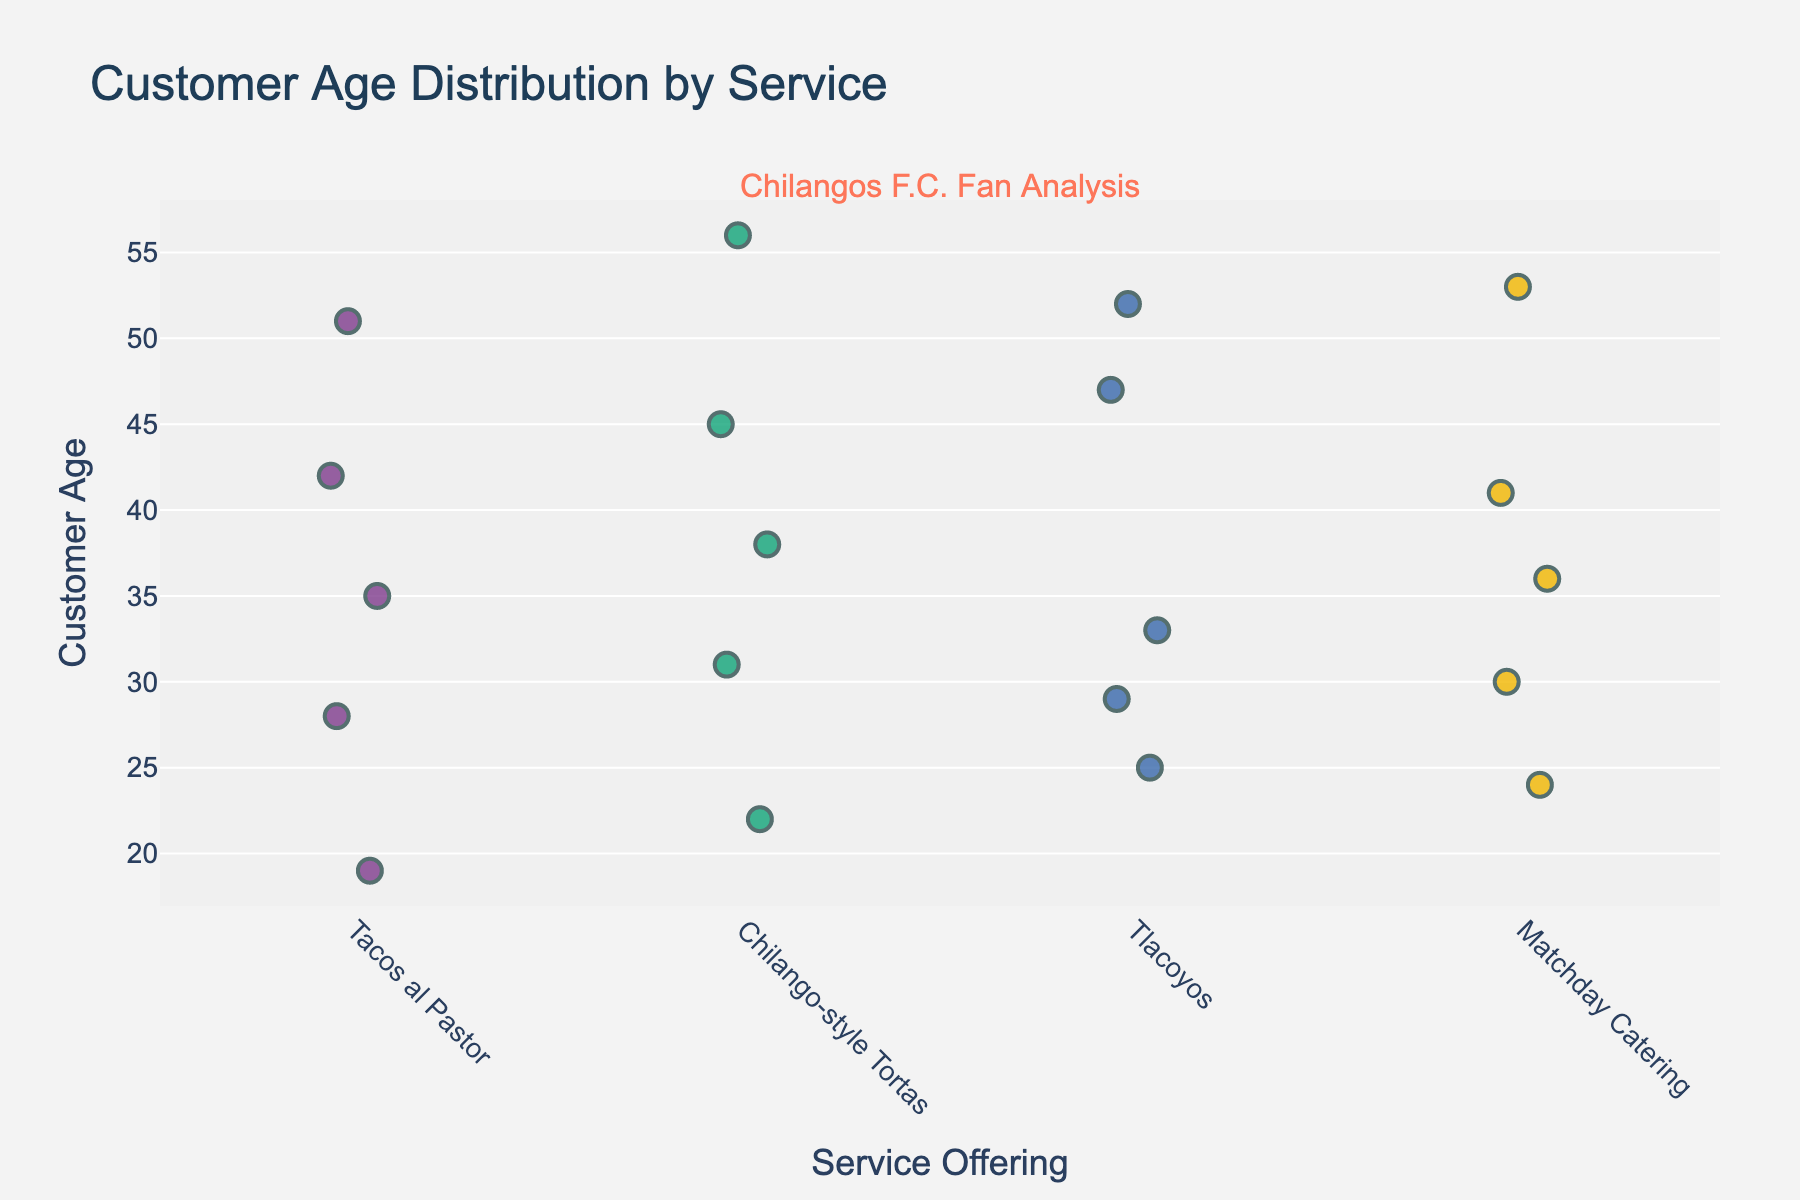How many unique service offerings are shown in the figure? Look at the x-axis of the figure, which lists the service offerings. Count the distinct labels.
Answer: 4 What's the title of the figure? Examine the top part of the figure where the title is usually displayed.
Answer: Customer Age Distribution by Service What is the age range for the Tacos al Pastor service offering? Identify the minimum and maximum ages represented in the strip plot for Tacos al Pastor.
Answer: 19-51 Which service shows the oldest customer? Find which service has the highest age marker on the y-axis.
Answer: Chilango-style Tortas What is the median age of customers for the Matchday Catering service? List the ages for Matchday Catering. Arrange them in ascending order and find the median position. The ages are (24, 30, 36, 41, 53); median age is the middle value.
Answer: 36 Which two services have customers with overlapping age ranges? Compare the age ranges for each service. Identify where the ranges intersect.
Answer: Tacos al Pastor and Chilango-style Tortas Which service has the youngest customer? Identify which service has the lowest age marker on the y-axis.
Answer: Tacos al Pastor How does the average customer age for Tlacoyos compare to Chilango-style Tortas? Calculate the average age for both services. For Tlacoyos (25+33+47+29+52)/5 = 37.2 and for Chilango-style Tortas (31+45+22+38+56)/5 = 38.4. Compare the two averages.
Answer: Tlacoyos: 37.2, Chilango-style Tortas: 38.4 What's the difference in the average ages between Tacos al Pastor and Matchday Catering? Calculate the average age for both services. For Tacos al Pastor (28+35+42+19+51)/5 = 35 and Matchday Catering (24+30+36+41+53)/5 = 36.8. Subtract Tacos al Pastor's average from Matchday Catering's.
Answer: 1.8 What can be inferred about the age distribution of customers for each service? Analyze the clustering and spread of age markers for each service. Services with more spread have more diverse age groups; closely clustered points indicate less variability in age.
Answer: Insights about age variability and clustering for each service 